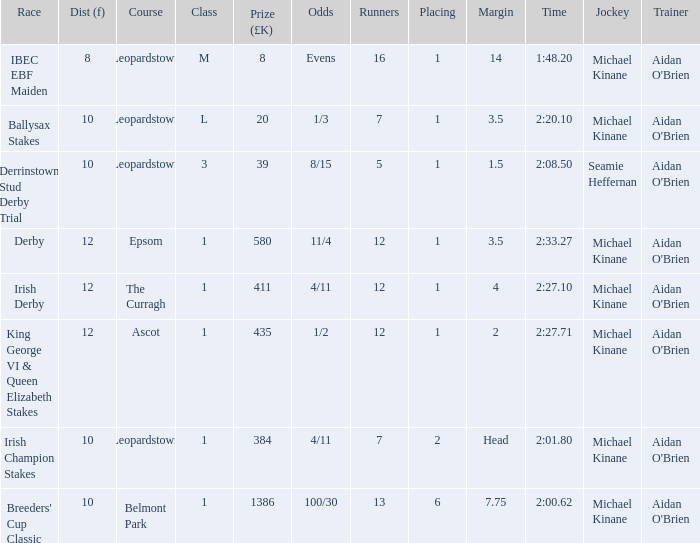Which Margin has a Dist (f) larger than 10, and a Race of king george vi & queen elizabeth stakes? 2.0. 